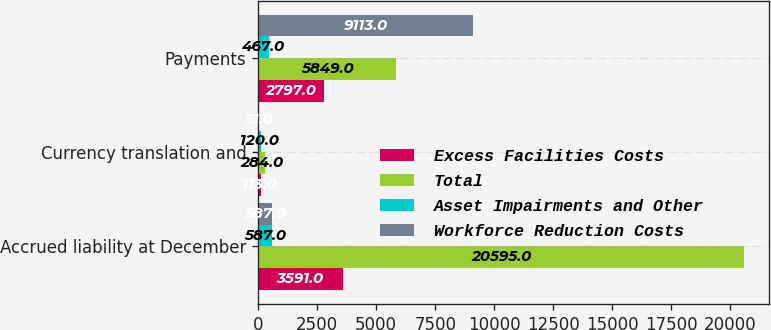Convert chart. <chart><loc_0><loc_0><loc_500><loc_500><stacked_bar_chart><ecel><fcel>Accrued liability at December<fcel>Currency translation and<fcel>Payments<nl><fcel>Excess Facilities Costs<fcel>3591<fcel>113<fcel>2797<nl><fcel>Total<fcel>20595<fcel>284<fcel>5849<nl><fcel>Asset Impairments and Other<fcel>587<fcel>120<fcel>467<nl><fcel>Workforce Reduction Costs<fcel>587<fcel>51<fcel>9113<nl></chart> 